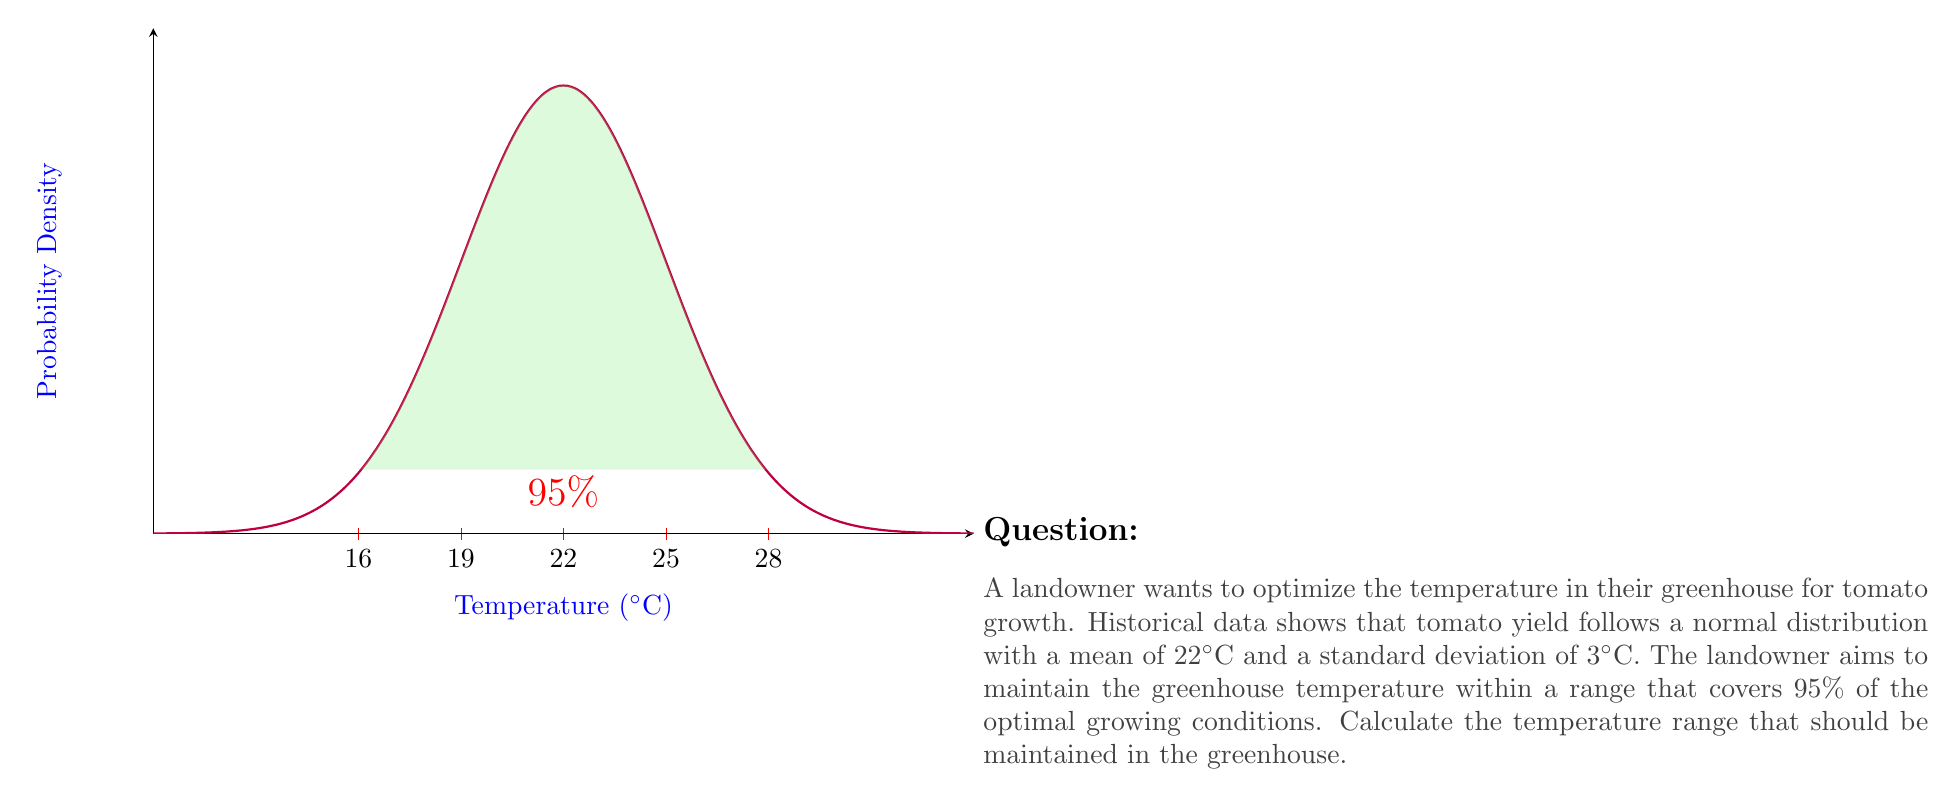Can you answer this question? To solve this problem, we'll use the properties of the normal distribution:

1) The normal distribution is symmetric around the mean.

2) For a 95% confidence interval, we need to include all values within 1.96 standard deviations of the mean on both sides.

3) The formula for the confidence interval is:

   $$[\mu - z \cdot \sigma, \mu + z \cdot \sigma]$$

   where $\mu$ is the mean, $\sigma$ is the standard deviation, and $z$ is the z-score (1.96 for 95% confidence).

4) Given:
   $\mu = 22°C$
   $\sigma = 3°C$
   $z = 1.96$ (for 95% confidence)

5) Calculate the lower bound:
   $$22 - (1.96 \cdot 3) = 22 - 5.88 = 16.12°C$$

6) Calculate the upper bound:
   $$22 + (1.96 \cdot 3) = 22 + 5.88 = 27.88°C$$

7) Round to one decimal place for practical use in a greenhouse setting.

Therefore, the temperature range that should be maintained is 16.1°C to 27.9°C.
Answer: 16.1°C to 27.9°C 